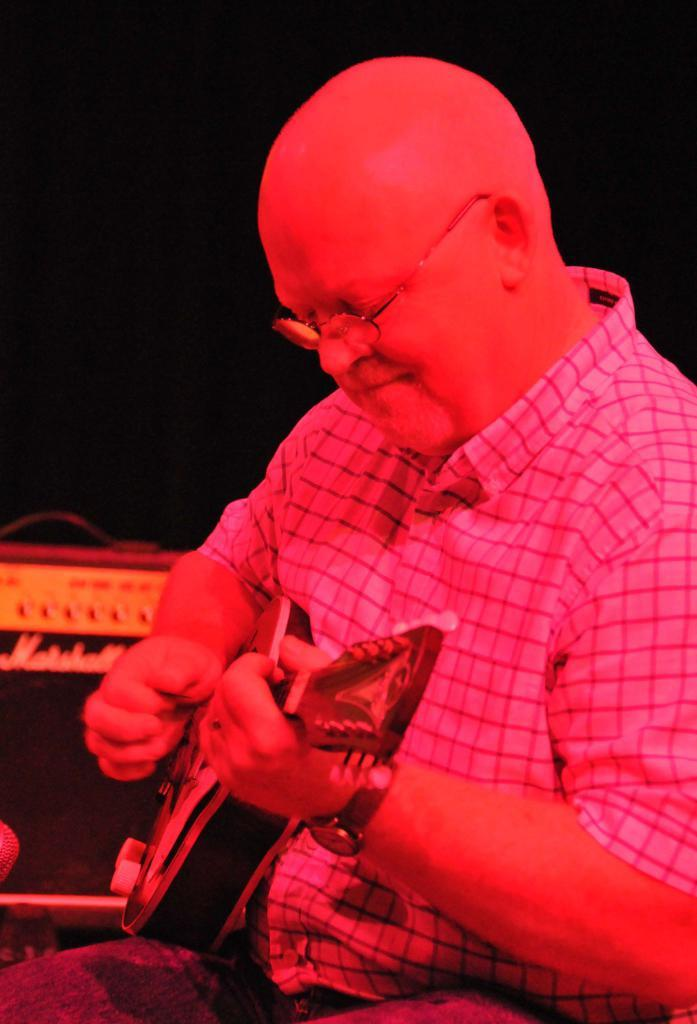What is the man in the image doing? The man is sitting and playing the guitar. What is the man wearing in the image? The man is wearing a shirt, spectacles, and trousers. What is the guitar in the image? The guitar is a musical instrument. What can be observed about the background of the image? The background of the image appears dark. How many watches can be seen on the man's wrist in the image? There are no watches visible on the man's wrist in the image. What type of structure is present behind the man in the image? There is no structure visible behind the man in the image. 